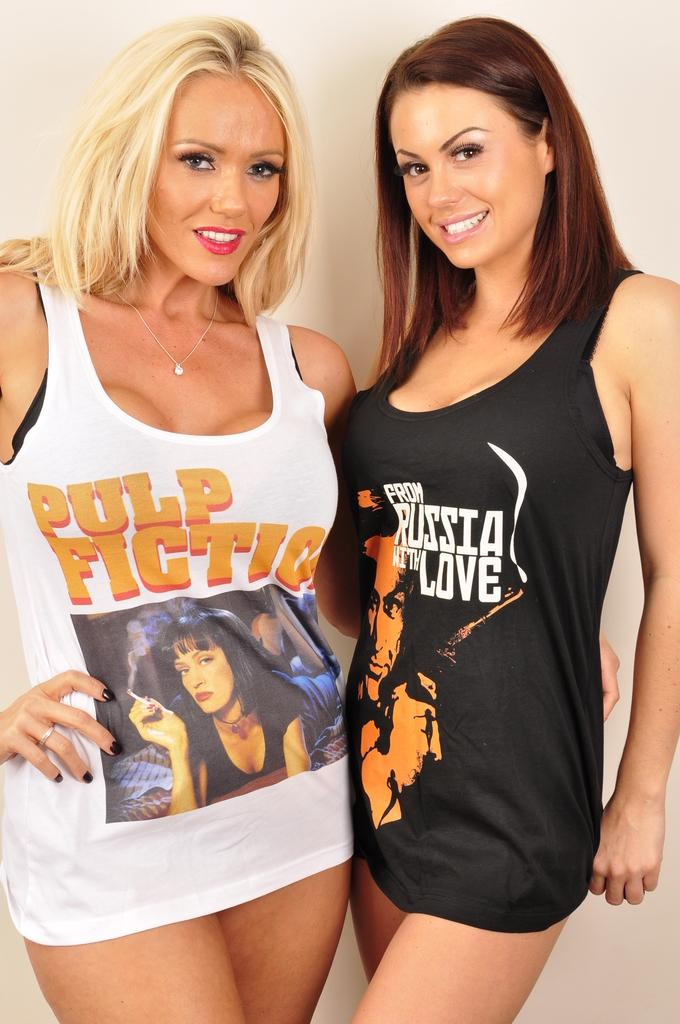<image>
Summarize the visual content of the image. Pulp Fiction and From Russia With Love are displayed on these two tank tops. 